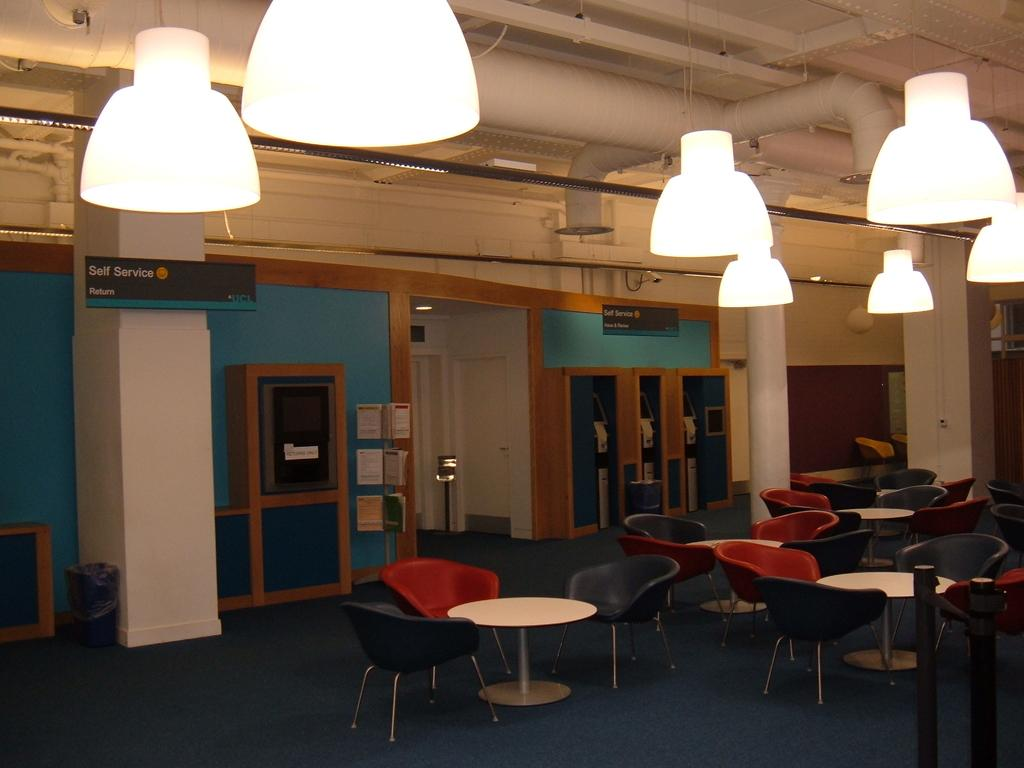What type of furniture can be seen in the image? There are chairs in the image. How are the tables arranged in the image? Tables are arranged in the image. What material are the shelves made of in the image? There are wooden shelves in the image. What type of lighting is present in the image? There are lights on the roof in the image. How does the plot of land in the image affect the arrangement of the chairs? There is no plot of land mentioned in the image; it only features chairs, tables, wooden shelves, and lights on the roof. Can you describe the texture of the slip in the image? There is no slip present in the image. 